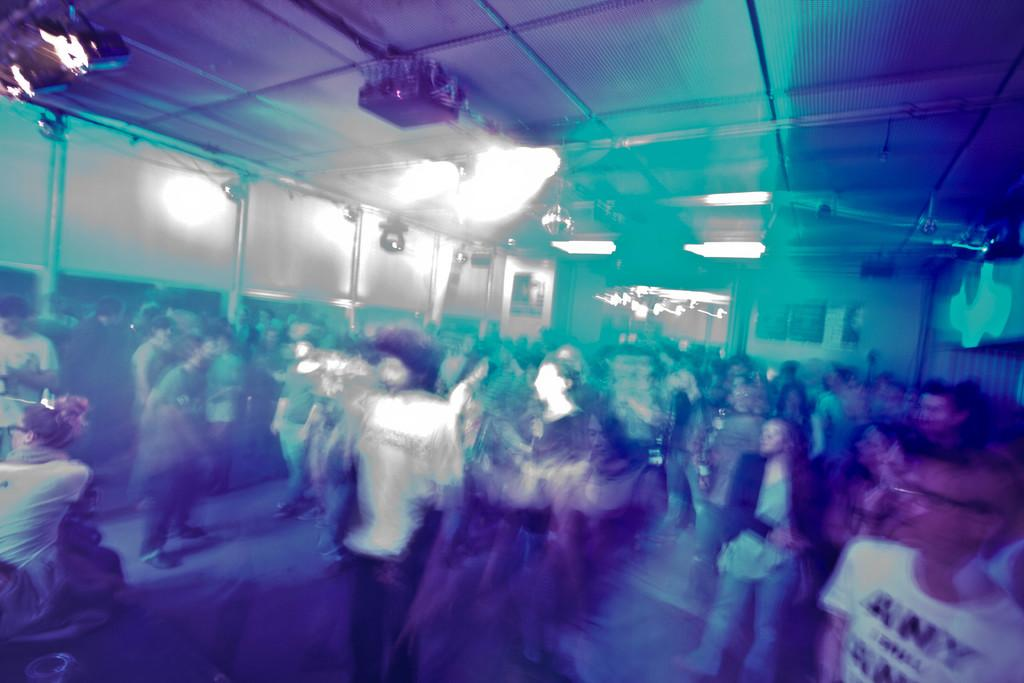How many people are present in the room? There are many people in the room. What can be seen on the top of the room? There are lights on the top of the room. What type of copy is being used as bait in the room? There is no copy or bait present in the room; the image only shows many people and lights on the top of the room. 